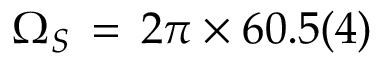<formula> <loc_0><loc_0><loc_500><loc_500>\Omega _ { S } \, = \, 2 \pi \times 6 0 . 5 ( 4 )</formula> 